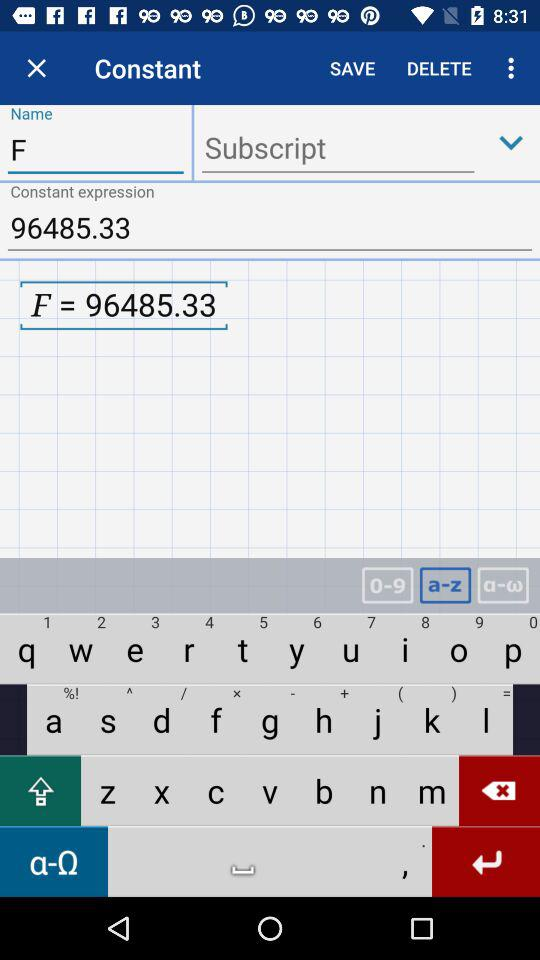What is the entered name? The entered name is F. 